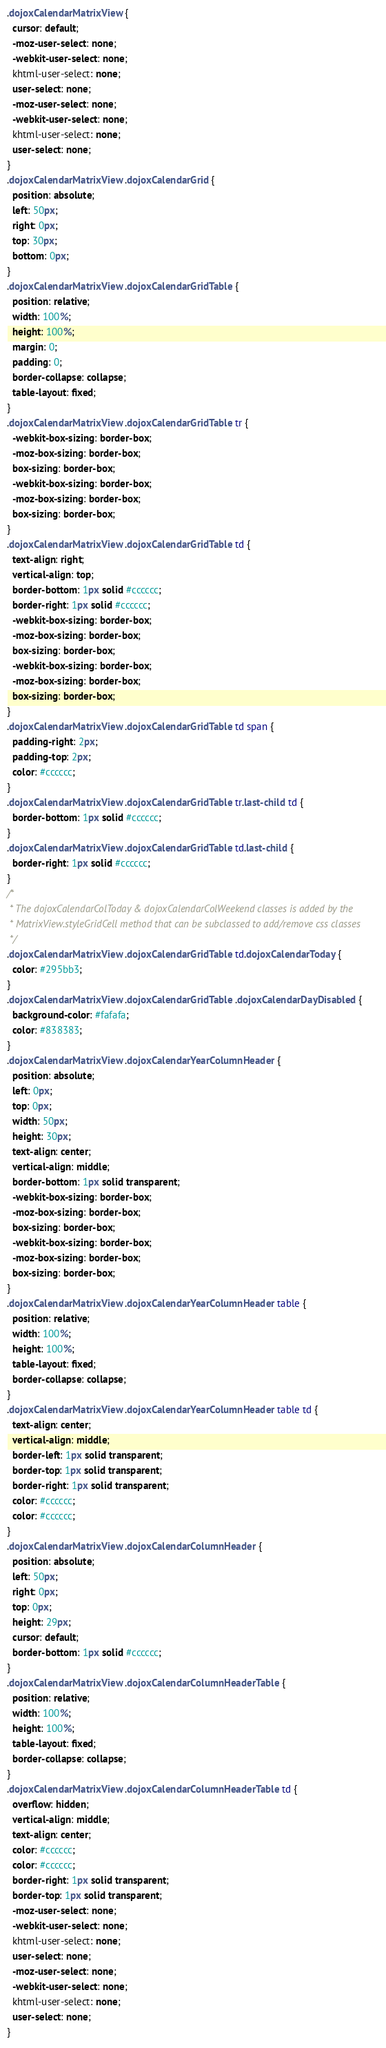Convert code to text. <code><loc_0><loc_0><loc_500><loc_500><_CSS_>.dojoxCalendarMatrixView {
  cursor: default;
  -moz-user-select: none;
  -webkit-user-select: none;
  khtml-user-select: none;
  user-select: none;
  -moz-user-select: none;
  -webkit-user-select: none;
  khtml-user-select: none;
  user-select: none;
}
.dojoxCalendarMatrixView .dojoxCalendarGrid {
  position: absolute;
  left: 50px;
  right: 0px;
  top: 30px;
  bottom: 0px;
}
.dojoxCalendarMatrixView .dojoxCalendarGridTable {
  position: relative;
  width: 100%;
  height: 100%;
  margin: 0;
  padding: 0;
  border-collapse: collapse;
  table-layout: fixed;
}
.dojoxCalendarMatrixView .dojoxCalendarGridTable tr {
  -webkit-box-sizing: border-box;
  -moz-box-sizing: border-box;
  box-sizing: border-box;
  -webkit-box-sizing: border-box;
  -moz-box-sizing: border-box;
  box-sizing: border-box;
}
.dojoxCalendarMatrixView .dojoxCalendarGridTable td {
  text-align: right;
  vertical-align: top;
  border-bottom: 1px solid #cccccc;
  border-right: 1px solid #cccccc;
  -webkit-box-sizing: border-box;
  -moz-box-sizing: border-box;
  box-sizing: border-box;
  -webkit-box-sizing: border-box;
  -moz-box-sizing: border-box;
  box-sizing: border-box;
}
.dojoxCalendarMatrixView .dojoxCalendarGridTable td span {
  padding-right: 2px;
  padding-top: 2px;
  color: #cccccc;
}
.dojoxCalendarMatrixView .dojoxCalendarGridTable tr.last-child td {
  border-bottom: 1px solid #cccccc;
}
.dojoxCalendarMatrixView .dojoxCalendarGridTable td.last-child {
  border-right: 1px solid #cccccc;
}
/* 
 * The dojoxCalendarColToday & dojoxCalendarColWeekend classes is added by the 
 * MatrixView.styleGridCell method that can be subclassed to add/remove css classes
 */
.dojoxCalendarMatrixView .dojoxCalendarGridTable td.dojoxCalendarToday {
  color: #295bb3;
}
.dojoxCalendarMatrixView .dojoxCalendarGridTable .dojoxCalendarDayDisabled {
  background-color: #fafafa;
  color: #838383;
}
.dojoxCalendarMatrixView .dojoxCalendarYearColumnHeader {
  position: absolute;
  left: 0px;
  top: 0px;
  width: 50px;
  height: 30px;
  text-align: center;
  vertical-align: middle;
  border-bottom: 1px solid transparent;
  -webkit-box-sizing: border-box;
  -moz-box-sizing: border-box;
  box-sizing: border-box;
  -webkit-box-sizing: border-box;
  -moz-box-sizing: border-box;
  box-sizing: border-box;
}
.dojoxCalendarMatrixView .dojoxCalendarYearColumnHeader table {
  position: relative;
  width: 100%;
  height: 100%;
  table-layout: fixed;
  border-collapse: collapse;
}
.dojoxCalendarMatrixView .dojoxCalendarYearColumnHeader table td {
  text-align: center;
  vertical-align: middle;
  border-left: 1px solid transparent;
  border-top: 1px solid transparent;
  border-right: 1px solid transparent;
  color: #cccccc;
  color: #cccccc;
}
.dojoxCalendarMatrixView .dojoxCalendarColumnHeader {
  position: absolute;
  left: 50px;
  right: 0px;
  top: 0px;
  height: 29px;
  cursor: default;
  border-bottom: 1px solid #cccccc;
}
.dojoxCalendarMatrixView .dojoxCalendarColumnHeaderTable {
  position: relative;
  width: 100%;
  height: 100%;
  table-layout: fixed;
  border-collapse: collapse;
}
.dojoxCalendarMatrixView .dojoxCalendarColumnHeaderTable td {
  overflow: hidden;
  vertical-align: middle;
  text-align: center;
  color: #cccccc;
  color: #cccccc;
  border-right: 1px solid transparent;
  border-top: 1px solid transparent;
  -moz-user-select: none;
  -webkit-user-select: none;
  khtml-user-select: none;
  user-select: none;
  -moz-user-select: none;
  -webkit-user-select: none;
  khtml-user-select: none;
  user-select: none;
}</code> 